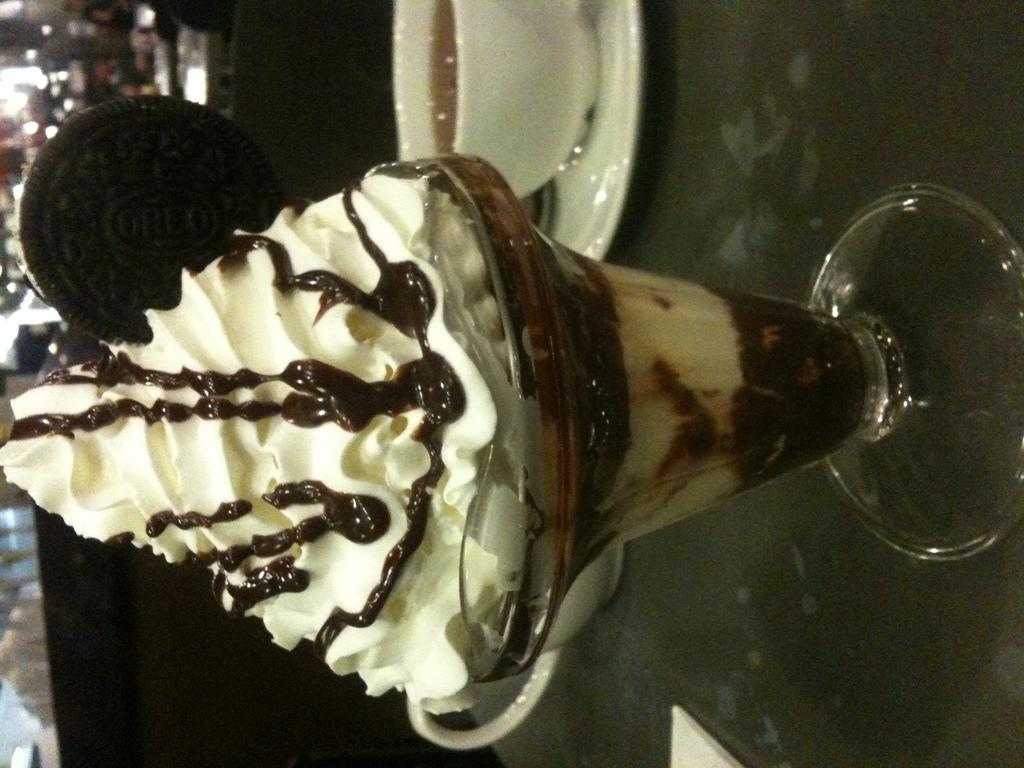What is in the glass that is visible in the image? There is an ice cream in the glass in the image. Where is the ice cream placed? The ice cream is placed on a table. What is in the cup that is visible in the image? There is coffee in the cup in the image. How is the cup with coffee positioned on the table? The cup is on a saucer, and both the cup and saucer are placed on the table. How many bikes are parked next to the table in the image? There are no bikes present in the image. What type of bun is placed on the saucer next to the cup? There is no bun present on the saucer or anywhere in the image. 